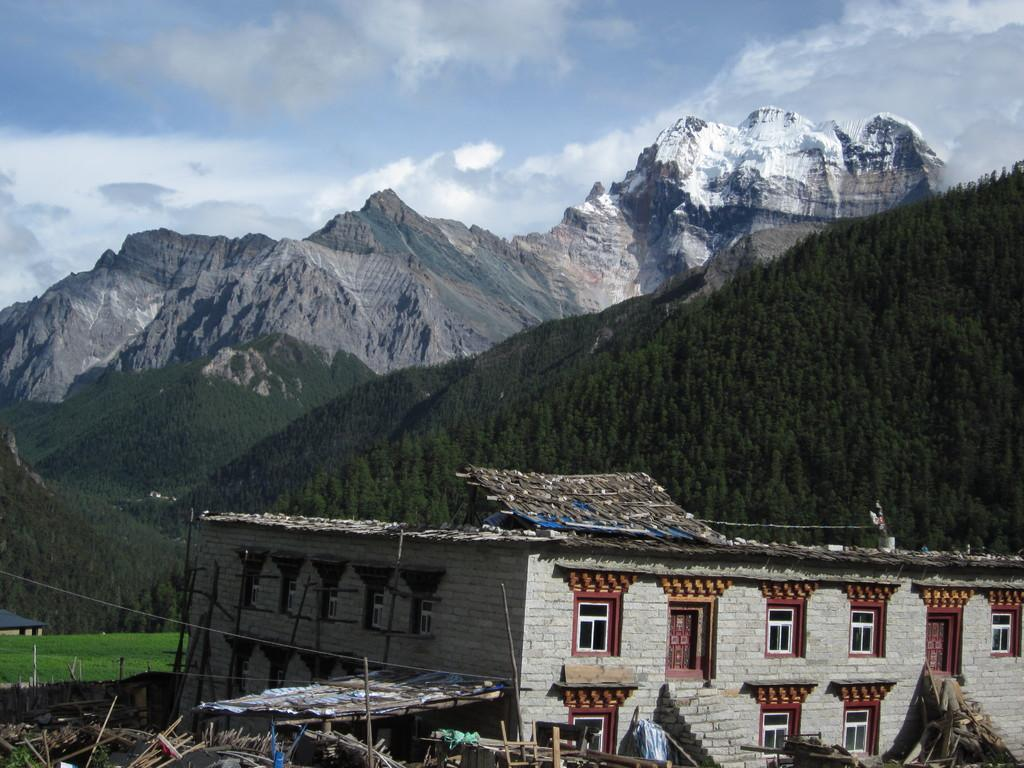What type of structures can be seen in the image? There are houses in the image. What architectural features are present on the houses? There are doors and windows in the image. How can people access the upper levels of the houses? There are stairs in the image. What type of vegetation is present in the image? A: There is grass and trees in the image. What is the natural landscape like in the image? There are hills in the image. What part of the natural environment is visible in the image? The sky is visible in the image, and there are clouds present. What type of pollution can be seen in the image? There is no pollution present in the image. What type of needle is used to sew the clouds in the image? There are no needles or sewing involved in the image; the clouds are a natural part of the sky. 